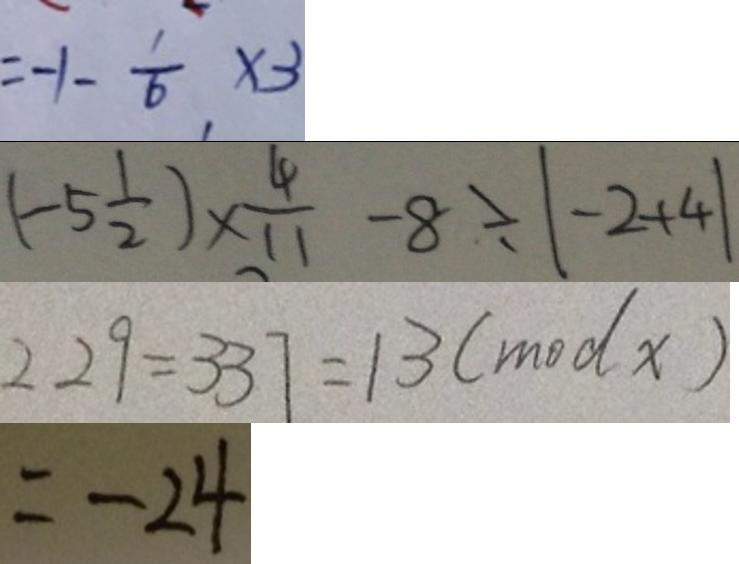<formula> <loc_0><loc_0><loc_500><loc_500>= - 1 - \frac { 1 } { 6 } \times 3 
 ( - 5 \frac { 1 } { 2 } ) \times \frac { 4 } { 1 1 } - 8 \div \vert - 2 + 4 \vert 
 2 2 9 = 3 3 7 = 1 3 ( m o d x ) 
 = - 2 4</formula> 